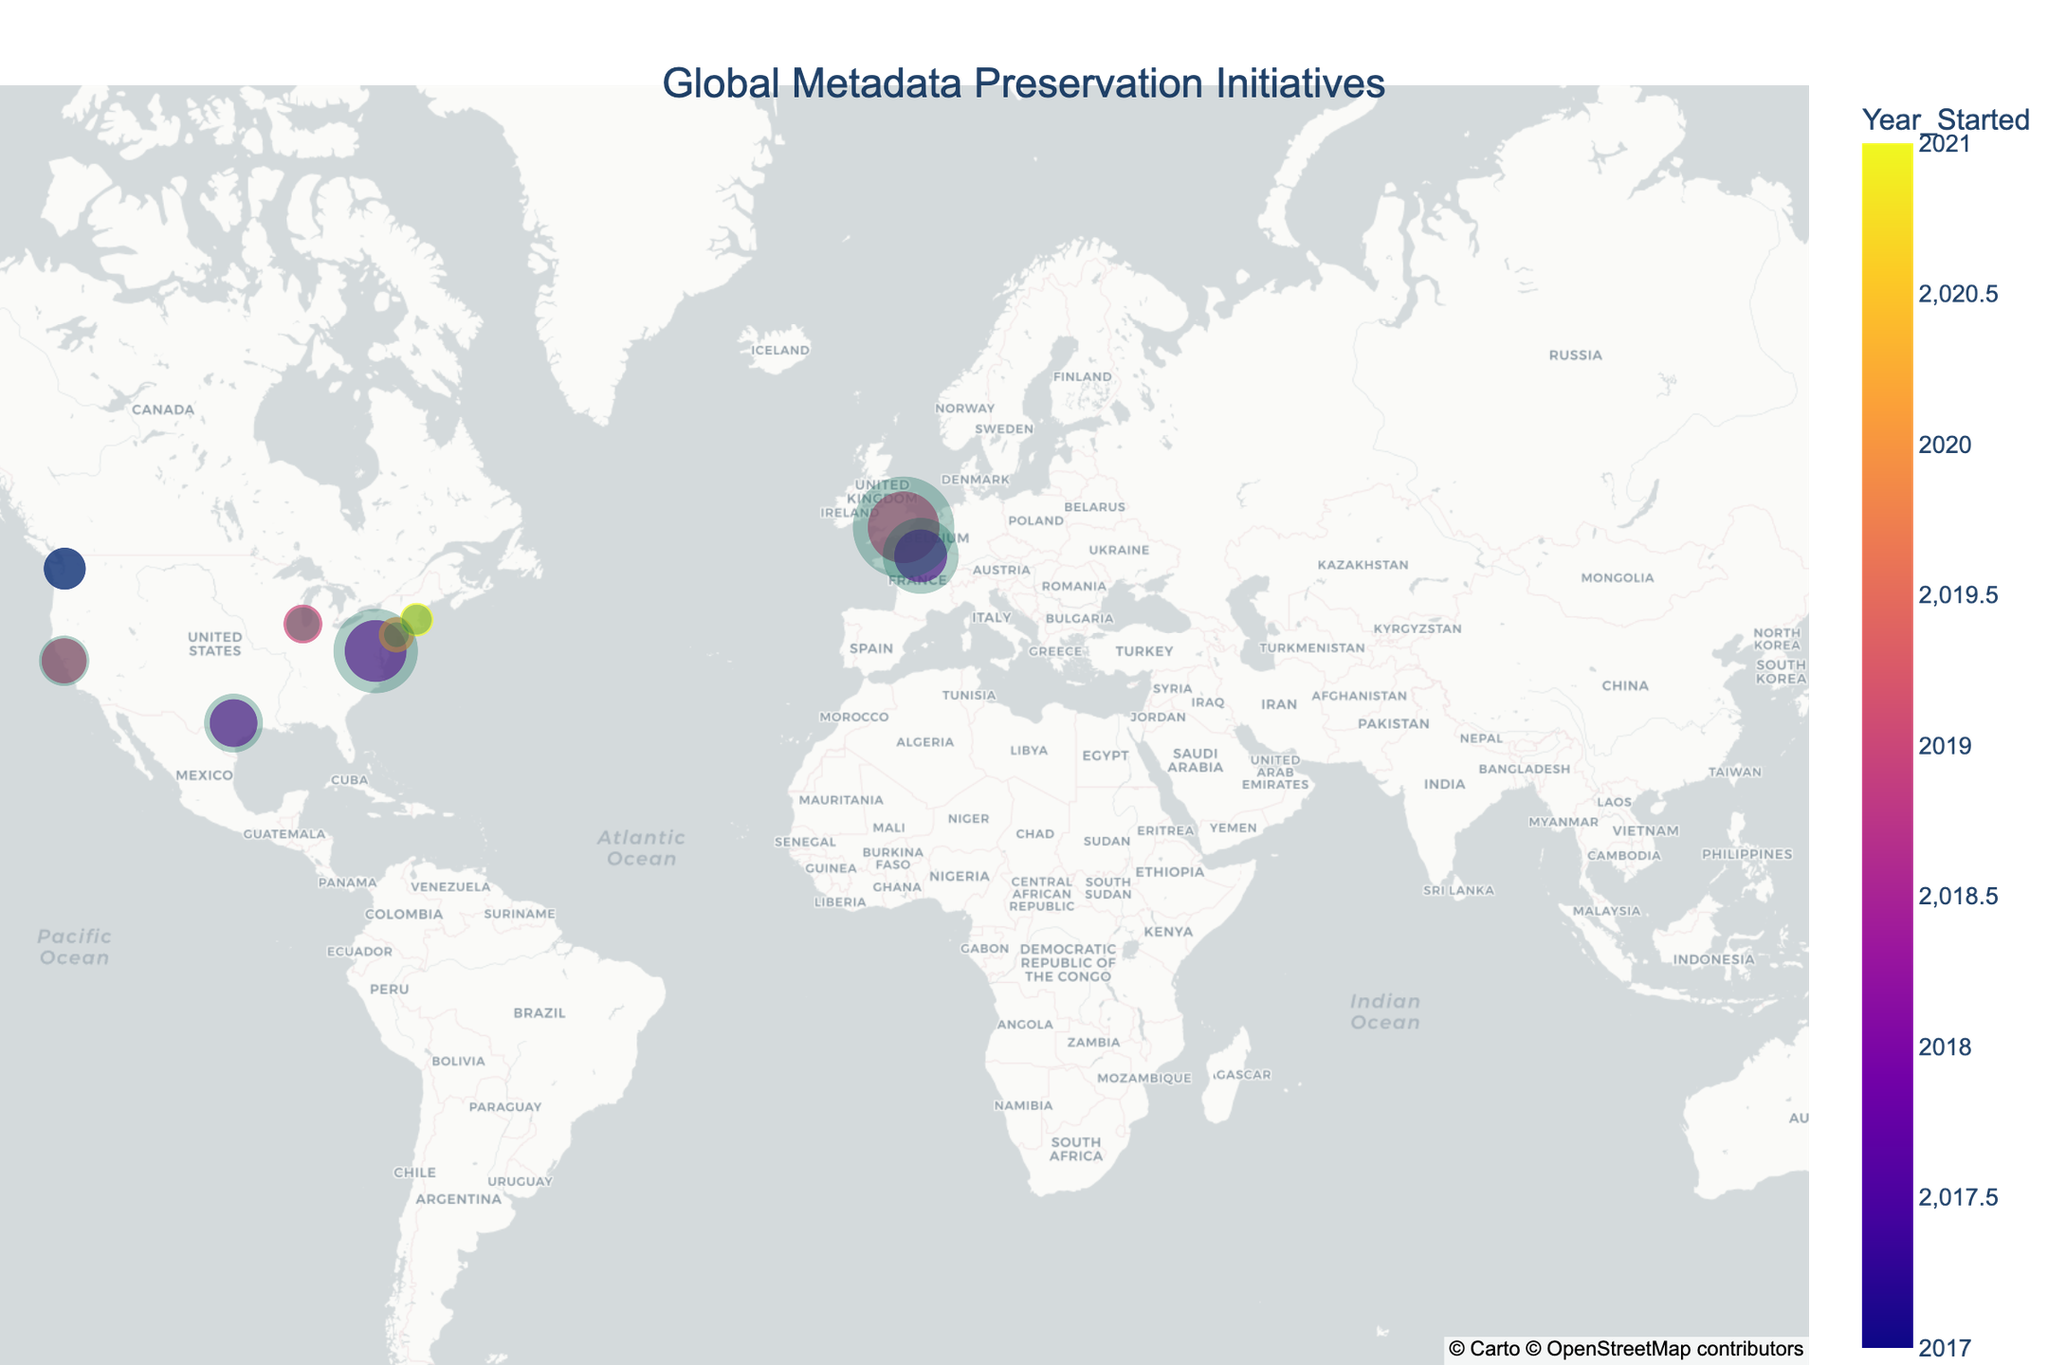What is the title of the figure? The title is usually displayed at the top of the figure. Here, it indicates the subject of the visualization which is "Global Metadata Preservation Initiatives".
Answer: Global Metadata Preservation Initiatives How many metadata preservation initiatives are shown on the map? Count the number of unique data points or markers on the map, each representing an initiative.
Answer: 10 Which initiative has the largest impact radius and what is its value? Look for the initiative with the largest circle (representing the largest impact radius) and check its size in the hover info. The UK National Data Strategy has the largest radius.
Answer: UK National Data Strategy, 600 km What year did the initiative with the green markers start? The color legend indicates that green corresponds to the year 2018. Identify the initiatives with green markers to find the year they started.
Answer: 2018 Which initiatives started in 2019? Refer to the color legend to find the markers colored for 2019 and then identify those initiatives through the hover information. Look for purple markers in this plot.
Answer: California Digital Library Metadata Project, Chicago Data Portal Metadata Enhancement, UK National Data Strategy What is the total funding amount for initiatives started in 2019? Identify the initiatives that started in 2019 and then sum their funding values. That would be California Digital Library Metadata Project ($8000000), Chicago Data Portal Metadata Enhancement ($6000000), and UK National Data Strategy ($20000000).
Answer: $34,000,000 Which initiative has the smallest funding amount, and what is its value? Look for the smallest-sized marker, which represents the funding amount. The Massachusetts Metadata Repository has the smallest funding amount.
Answer: Massachusetts Metadata Repository, $4,500,000 Which two initiatives are geographically the closest to each other? Visually inspect the map to determine the markers that are closest to each other geographically. The NYC Open Data Metadata Standards and Chicago Data Portal Metadata Enhancement appear closest.
Answer: NYC Open Data Metadata Standards and Chicago Data Portal Metadata Enhancement How many initiatives have an impact radius greater than 300 km? Identify and count the circles representing initiatives with a radius larger than 300 km. Washington State Digital Archives, Texas Digital Library Consortium, UK National Data Strategy, French National Library Metadata Initiative, Tokyo Digital Archives Collaboration.
Answer: 5 Which country has the most initiatives, and how many are there? Examine the geographic locations of the markers and identify which country contains the most initiatives. The United States has the most.
Answer: United States, 6 